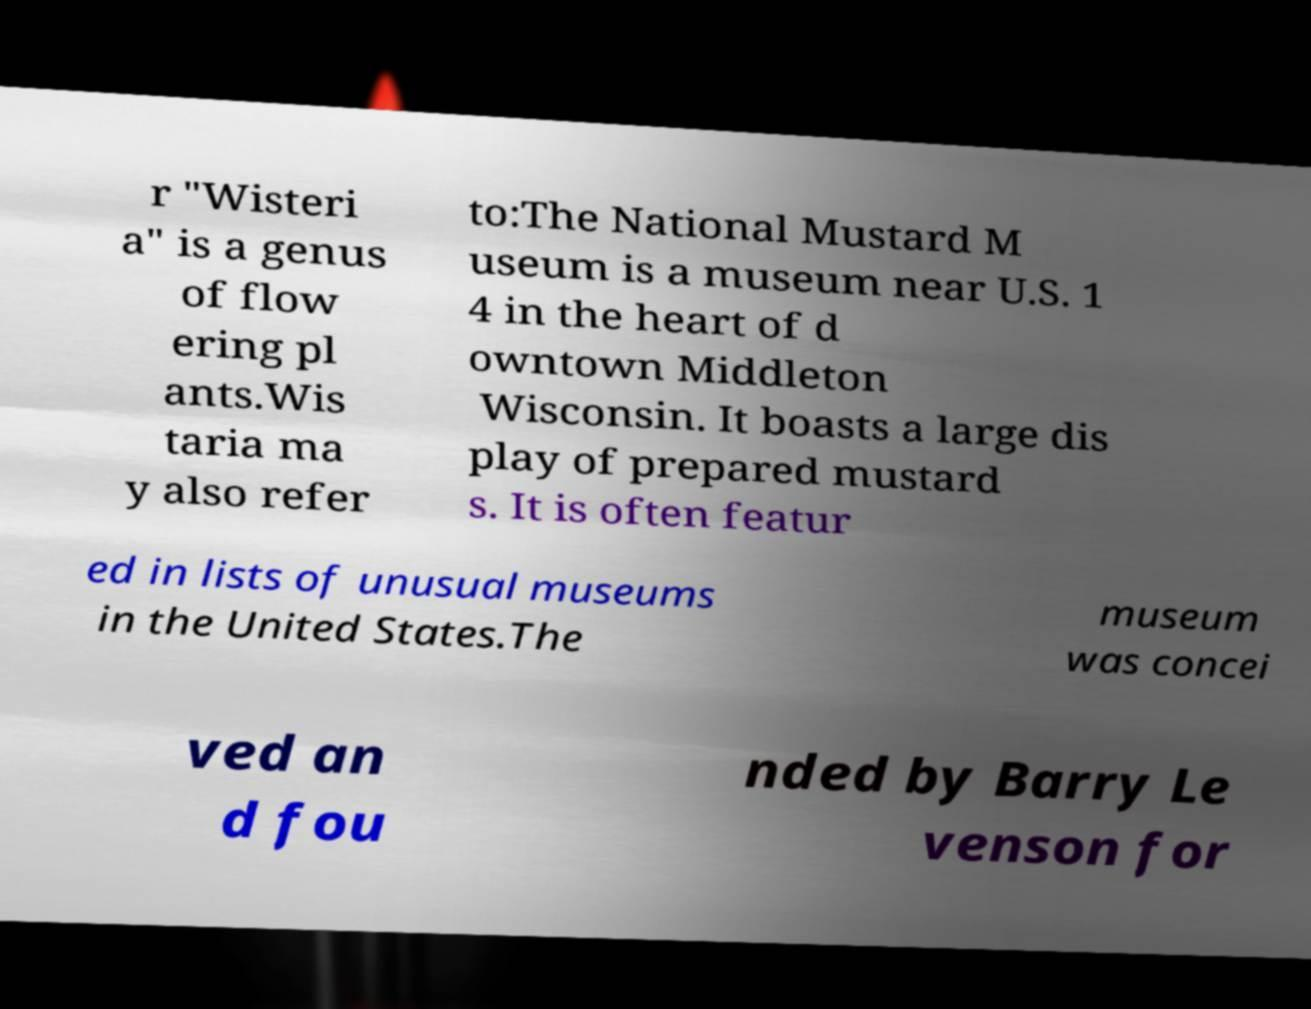I need the written content from this picture converted into text. Can you do that? r "Wisteri a" is a genus of flow ering pl ants.Wis taria ma y also refer to:The National Mustard M useum is a museum near U.S. 1 4 in the heart of d owntown Middleton Wisconsin. It boasts a large dis play of prepared mustard s. It is often featur ed in lists of unusual museums in the United States.The museum was concei ved an d fou nded by Barry Le venson for 